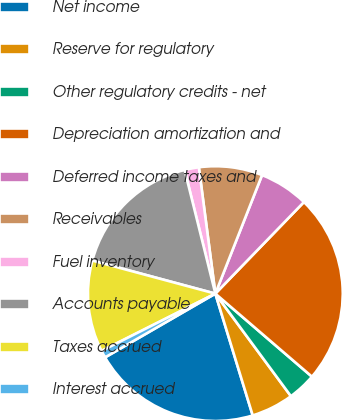<chart> <loc_0><loc_0><loc_500><loc_500><pie_chart><fcel>Net income<fcel>Reserve for regulatory<fcel>Other regulatory credits - net<fcel>Depreciation amortization and<fcel>Deferred income taxes and<fcel>Receivables<fcel>Fuel inventory<fcel>Accounts payable<fcel>Taxes accrued<fcel>Interest accrued<nl><fcel>21.39%<fcel>5.37%<fcel>3.59%<fcel>24.06%<fcel>6.26%<fcel>8.04%<fcel>1.81%<fcel>16.94%<fcel>11.6%<fcel>0.92%<nl></chart> 